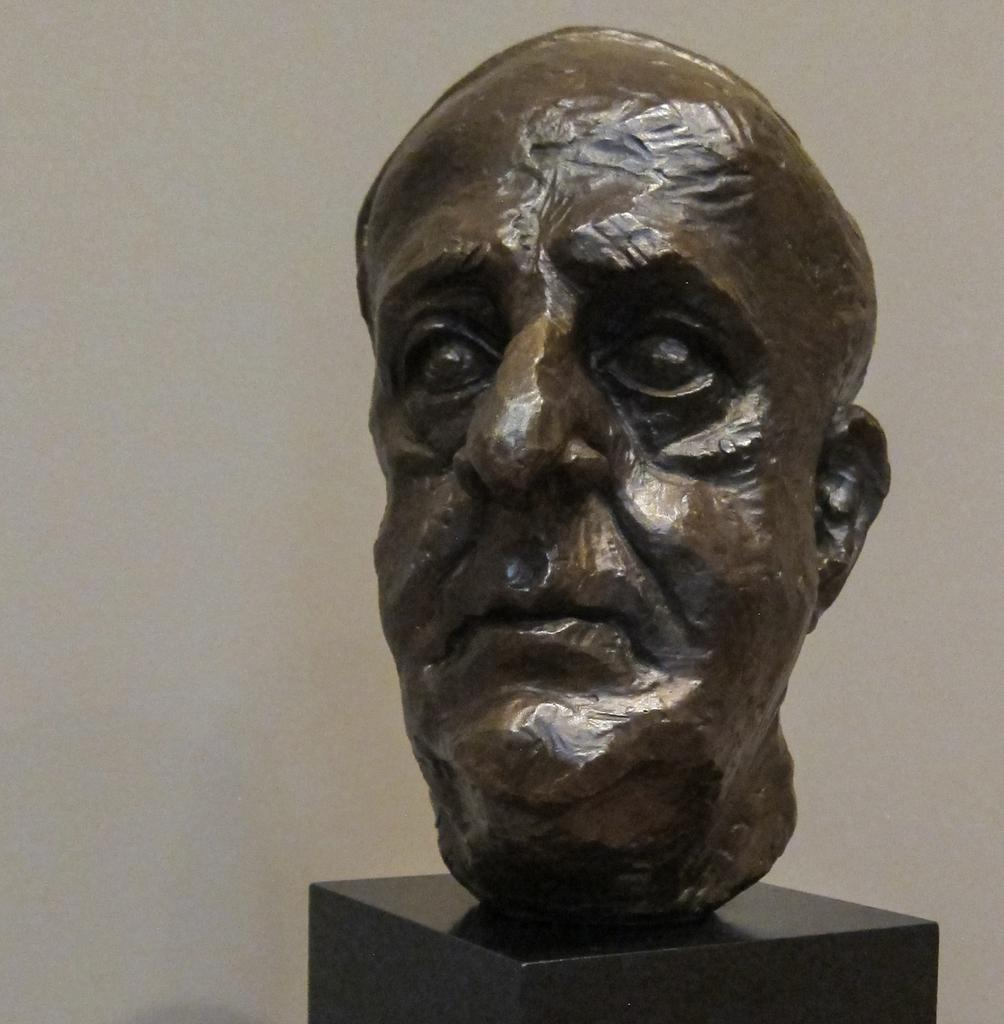What is the main subject of the image? There is a statue in the image. What does the statue represent? The statue is of a person's face. What color is the surface on which the statue is placed? The statue is on a black color surface. What color is the background of the image? The background of the image is white. Can you see any bees or lettuce near the statue in the image? No, there are no bees or lettuce present in the image. Is there a cactus growing on the statue's face in the image? No, there is no cactus growing on the statue's face in the image. 